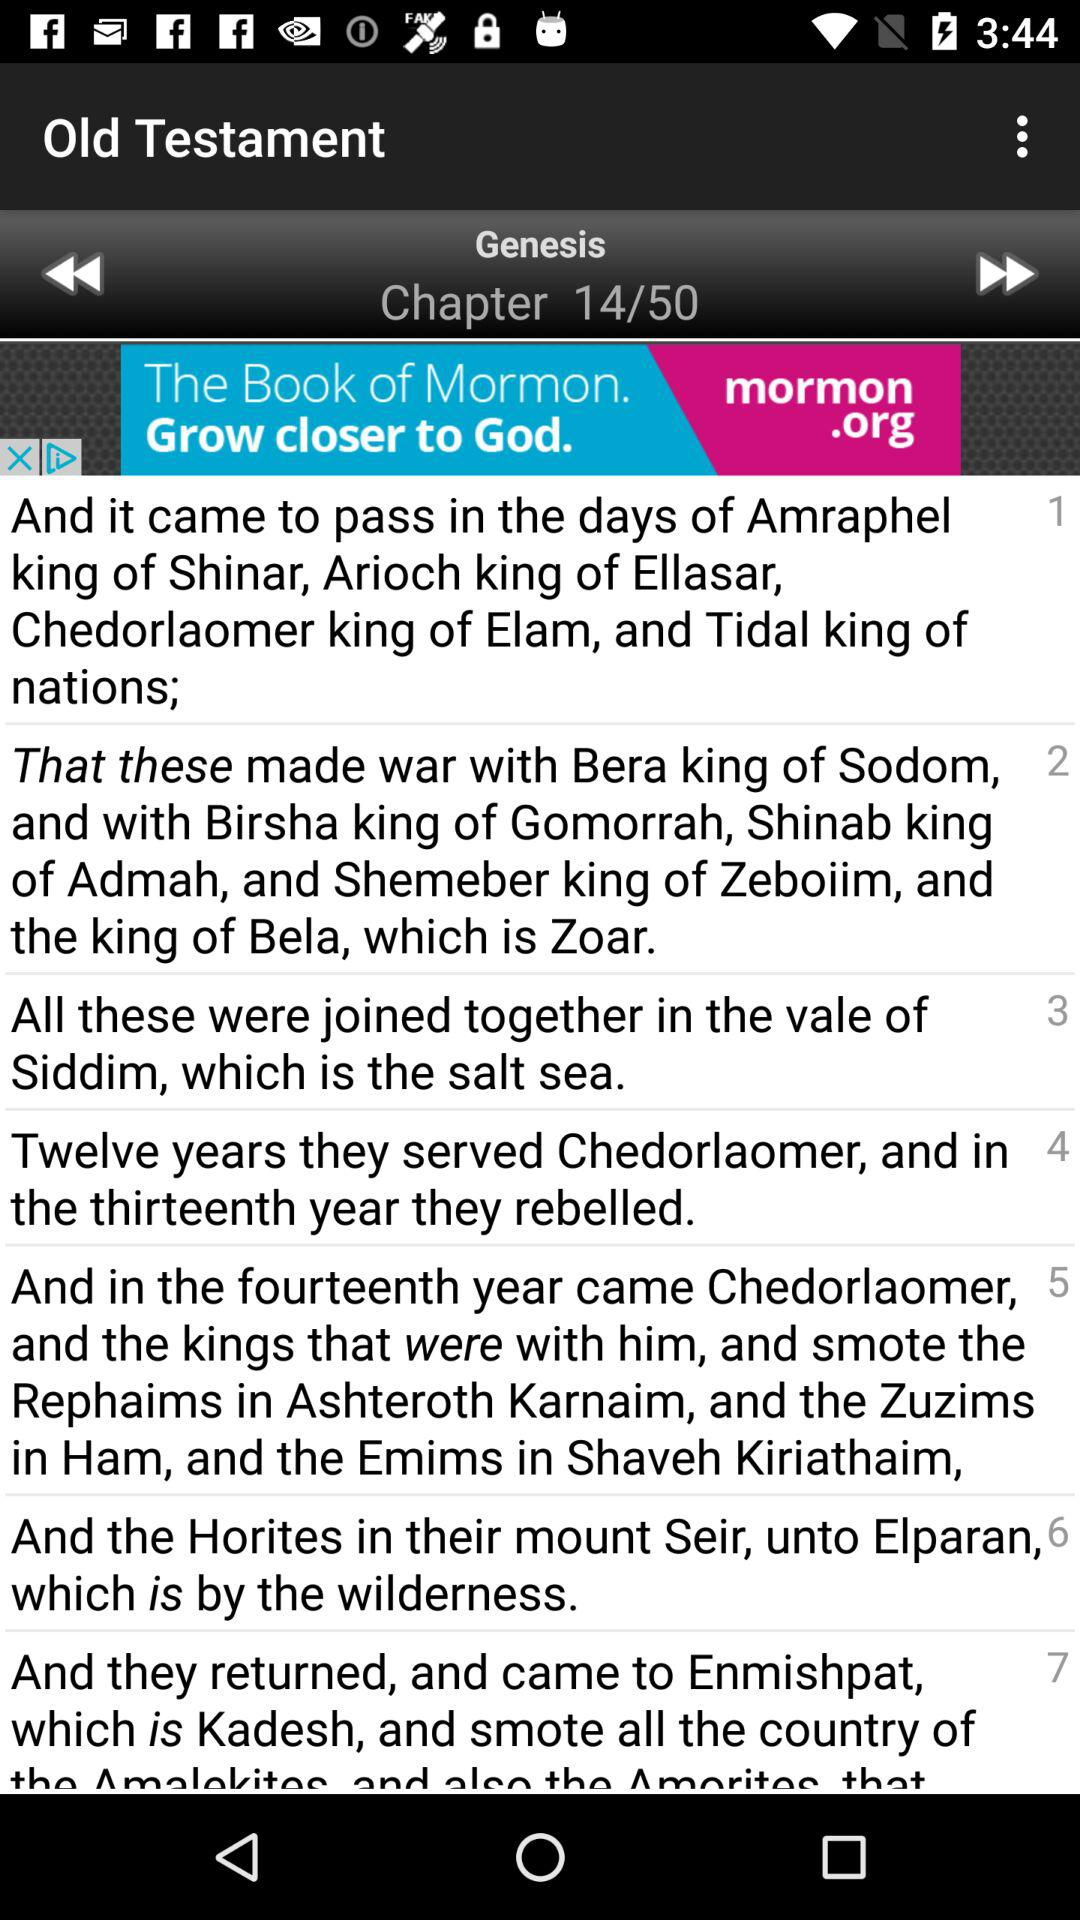What's the total number of chapters in the "Genesis" book? The total number of chapters in the "Genesis" book is 50. 